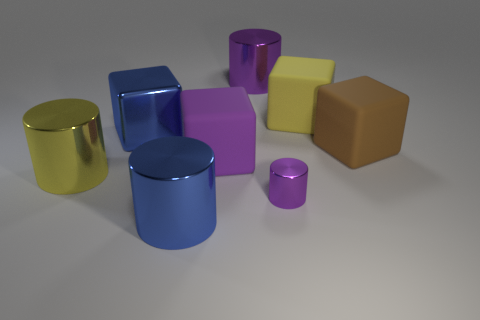Do the tiny metallic thing and the large metallic block have the same color?
Give a very brief answer. No. What is the color of the block that is the same material as the small purple cylinder?
Provide a short and direct response. Blue. Is the material of the large yellow cylinder the same as the big purple object behind the large brown thing?
Your answer should be compact. Yes. What number of large yellow blocks have the same material as the big brown cube?
Give a very brief answer. 1. The blue shiny object behind the tiny purple cylinder has what shape?
Your answer should be very brief. Cube. Does the large blue thing left of the blue cylinder have the same material as the yellow object in front of the yellow matte thing?
Make the answer very short. Yes. Is there a big purple metallic thing that has the same shape as the purple rubber object?
Offer a very short reply. No. How many objects are blocks to the left of the yellow block or big yellow rubber cubes?
Your answer should be very brief. 3. Are there more objects that are behind the yellow matte thing than large purple blocks that are in front of the yellow shiny cylinder?
Keep it short and to the point. Yes. How many rubber objects are yellow things or large cylinders?
Give a very brief answer. 1. 